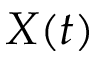Convert formula to latex. <formula><loc_0><loc_0><loc_500><loc_500>X ( t )</formula> 